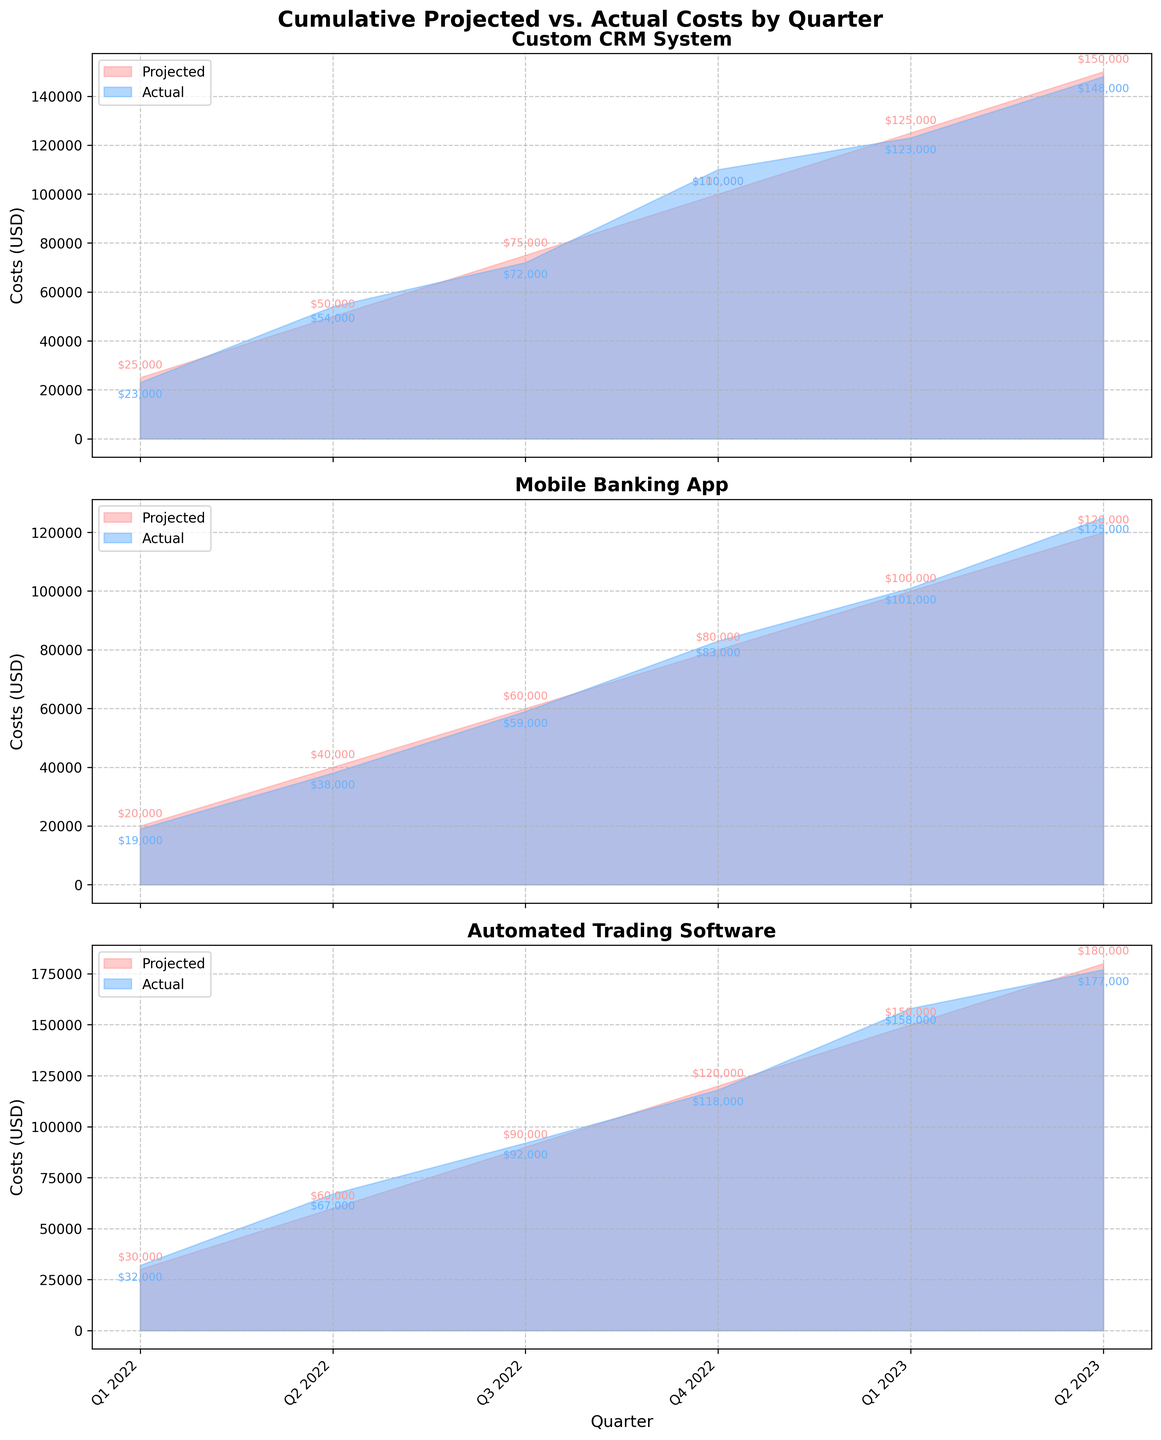What is the title of the figure? The title of the figure is located at the top and often provides a summary of what the figure represents. In this case, it reads "Cumulative Projected vs. Actual Costs by Quarter." From this title, we can infer that the figure is comparing the projected costs versus the actual costs over time, broken down by quarter.
Answer: Cumulative Projected vs. Actual Costs by Quarter How many projects are compared in the figure? To determine the number of projects, we can count the number of subplots. Each subplot represents a different project. Here, there are three subplots which correspond to three different projects.
Answer: 3 Which project had the highest actual cost in Q2 2022? We observe the actual cost values in Q2 2022 for each subplot. For the "Custom CRM System" the actual cost is $54,000, for the "Mobile Banking App" it is $38,000, and for the "Automated Trading Software" it is $67,000. The "Automated Trading Software" had the highest actual cost in Q2 2022.
Answer: Automated Trading Software What is the difference between projected and actual costs for the Mobile Banking App in Q2 2023? We extract the projected and actual costs for the Mobile Banking App in Q2 2023. The projected cost is $120,000, while the actual cost is $125,000. The difference is calculated as $125,000 - $120,000 = $5,000.
Answer: $5,000 Has any project consistently had actual costs higher than projected costs from Q1 2022 to Q2 2023? For each project, we need to compare the actual costs to the projected costs for every quarter from Q1 2022 to Q2 2023. Only consider projects where the actual costs are higher for all quarters. The "Automated Trading Software" consistently shows actual costs higher than projected.
Answer: Automated Trading Software Which project had the greatest increase in actual costs between Q1 2022 and Q2 2023? We need to calculate the difference in actual costs between Q1 2022 and Q2 2023 for each project. The differences are:
- Custom CRM System: $148,000 - $23,000 = $125,000
- Mobile Banking App: $125,000 - $19,000 = $106,000
- Automated Trading Software: $177,000 - $32,000 = $145,000
The greatest increase is for the "Automated Trading Software".
Answer: Automated Trading Software In which quarter did the Custom CRM System experience a significant jump in actual costs? By examining the actual costs for the Custom CRM System, the costs jumped from $72,000 in Q3 2022 to $110,000 in Q4 2022, which is a significant increase.
Answer: Q4 2022 What trend can be observed for the projected costs of the Custom CRM System from Q1 2022 to Q2 2023? Observing the projected costs for the Custom CRM System each quarter, we see a steady increase from $25,000 in Q1 2022 to $150,000 in Q2 2023, indicating a continuous upward trend.
Answer: Steady increase How do the actual costs for the Automated Trading Software in Q1 2023 compare to the projected costs for the same quarter? For Q1 2023, the projected cost of the Automated Trading Software is $150,000, and the actual cost is $158,000. The actual cost is higher than the projected cost.
Answer: Actual costs are higher 